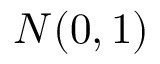<formula> <loc_0><loc_0><loc_500><loc_500>N ( 0 , 1 )</formula> 